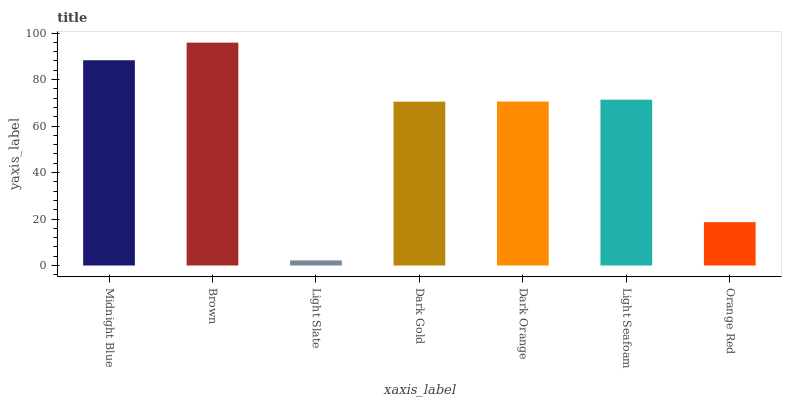Is Light Slate the minimum?
Answer yes or no. Yes. Is Brown the maximum?
Answer yes or no. Yes. Is Brown the minimum?
Answer yes or no. No. Is Light Slate the maximum?
Answer yes or no. No. Is Brown greater than Light Slate?
Answer yes or no. Yes. Is Light Slate less than Brown?
Answer yes or no. Yes. Is Light Slate greater than Brown?
Answer yes or no. No. Is Brown less than Light Slate?
Answer yes or no. No. Is Dark Orange the high median?
Answer yes or no. Yes. Is Dark Orange the low median?
Answer yes or no. Yes. Is Orange Red the high median?
Answer yes or no. No. Is Dark Gold the low median?
Answer yes or no. No. 